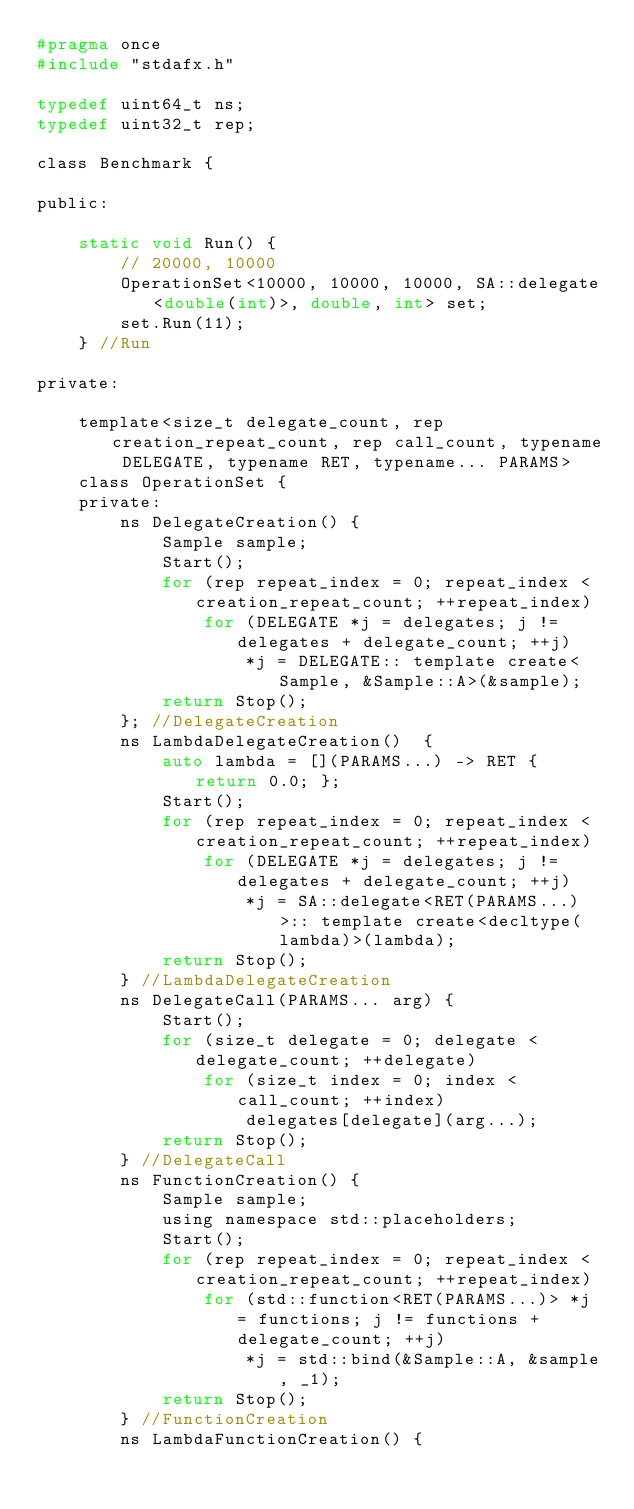<code> <loc_0><loc_0><loc_500><loc_500><_C_>#pragma once
#include "stdafx.h"

typedef uint64_t ns;
typedef uint32_t rep;

class Benchmark {

public:

	static void Run() {
		// 20000, 10000
		OperationSet<10000, 10000, 10000, SA::delegate<double(int)>, double, int> set;
		set.Run(11);
	} //Run

private:

	template<size_t delegate_count, rep creation_repeat_count, rep call_count, typename DELEGATE, typename RET, typename... PARAMS>
	class OperationSet {
	private:
		ns DelegateCreation() {
			Sample sample;
			Start();
			for (rep repeat_index = 0; repeat_index < creation_repeat_count; ++repeat_index)
				for (DELEGATE *j = delegates; j != delegates + delegate_count; ++j)
					*j = DELEGATE:: template create<Sample, &Sample::A>(&sample);
			return Stop();
		}; //DelegateCreation
		ns LambdaDelegateCreation()  {
			auto lambda = [](PARAMS...) -> RET { return 0.0; };
			Start();
			for (rep repeat_index = 0; repeat_index < creation_repeat_count; ++repeat_index)
				for (DELEGATE *j = delegates; j != delegates + delegate_count; ++j)
					*j = SA::delegate<RET(PARAMS...)>:: template create<decltype(lambda)>(lambda);
			return Stop();
		} //LambdaDelegateCreation
		ns DelegateCall(PARAMS... arg) {
			Start();
			for (size_t delegate = 0; delegate < delegate_count; ++delegate)
				for (size_t index = 0; index < call_count; ++index)
					delegates[delegate](arg...);
			return Stop();
		} //DelegateCall
		ns FunctionCreation() {
			Sample sample;
			using namespace std::placeholders;
			Start();
			for (rep repeat_index = 0; repeat_index < creation_repeat_count; ++repeat_index)
				for (std::function<RET(PARAMS...)> *j = functions; j != functions + delegate_count; ++j)
					*j = std::bind(&Sample::A, &sample, _1);
			return Stop();
		} //FunctionCreation
		ns LambdaFunctionCreation() {</code> 